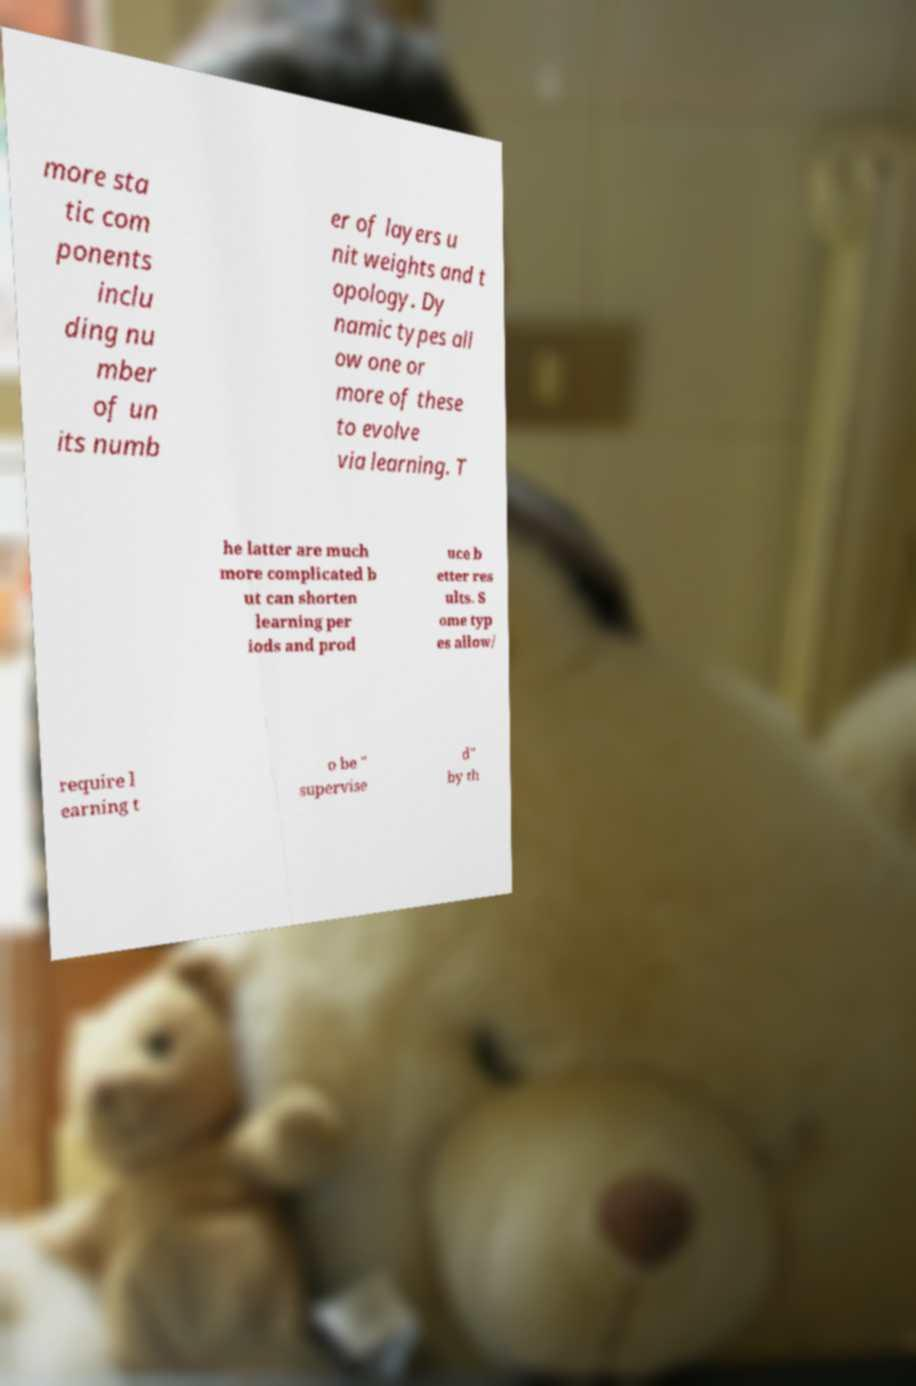Could you extract and type out the text from this image? more sta tic com ponents inclu ding nu mber of un its numb er of layers u nit weights and t opology. Dy namic types all ow one or more of these to evolve via learning. T he latter are much more complicated b ut can shorten learning per iods and prod uce b etter res ults. S ome typ es allow/ require l earning t o be " supervise d" by th 